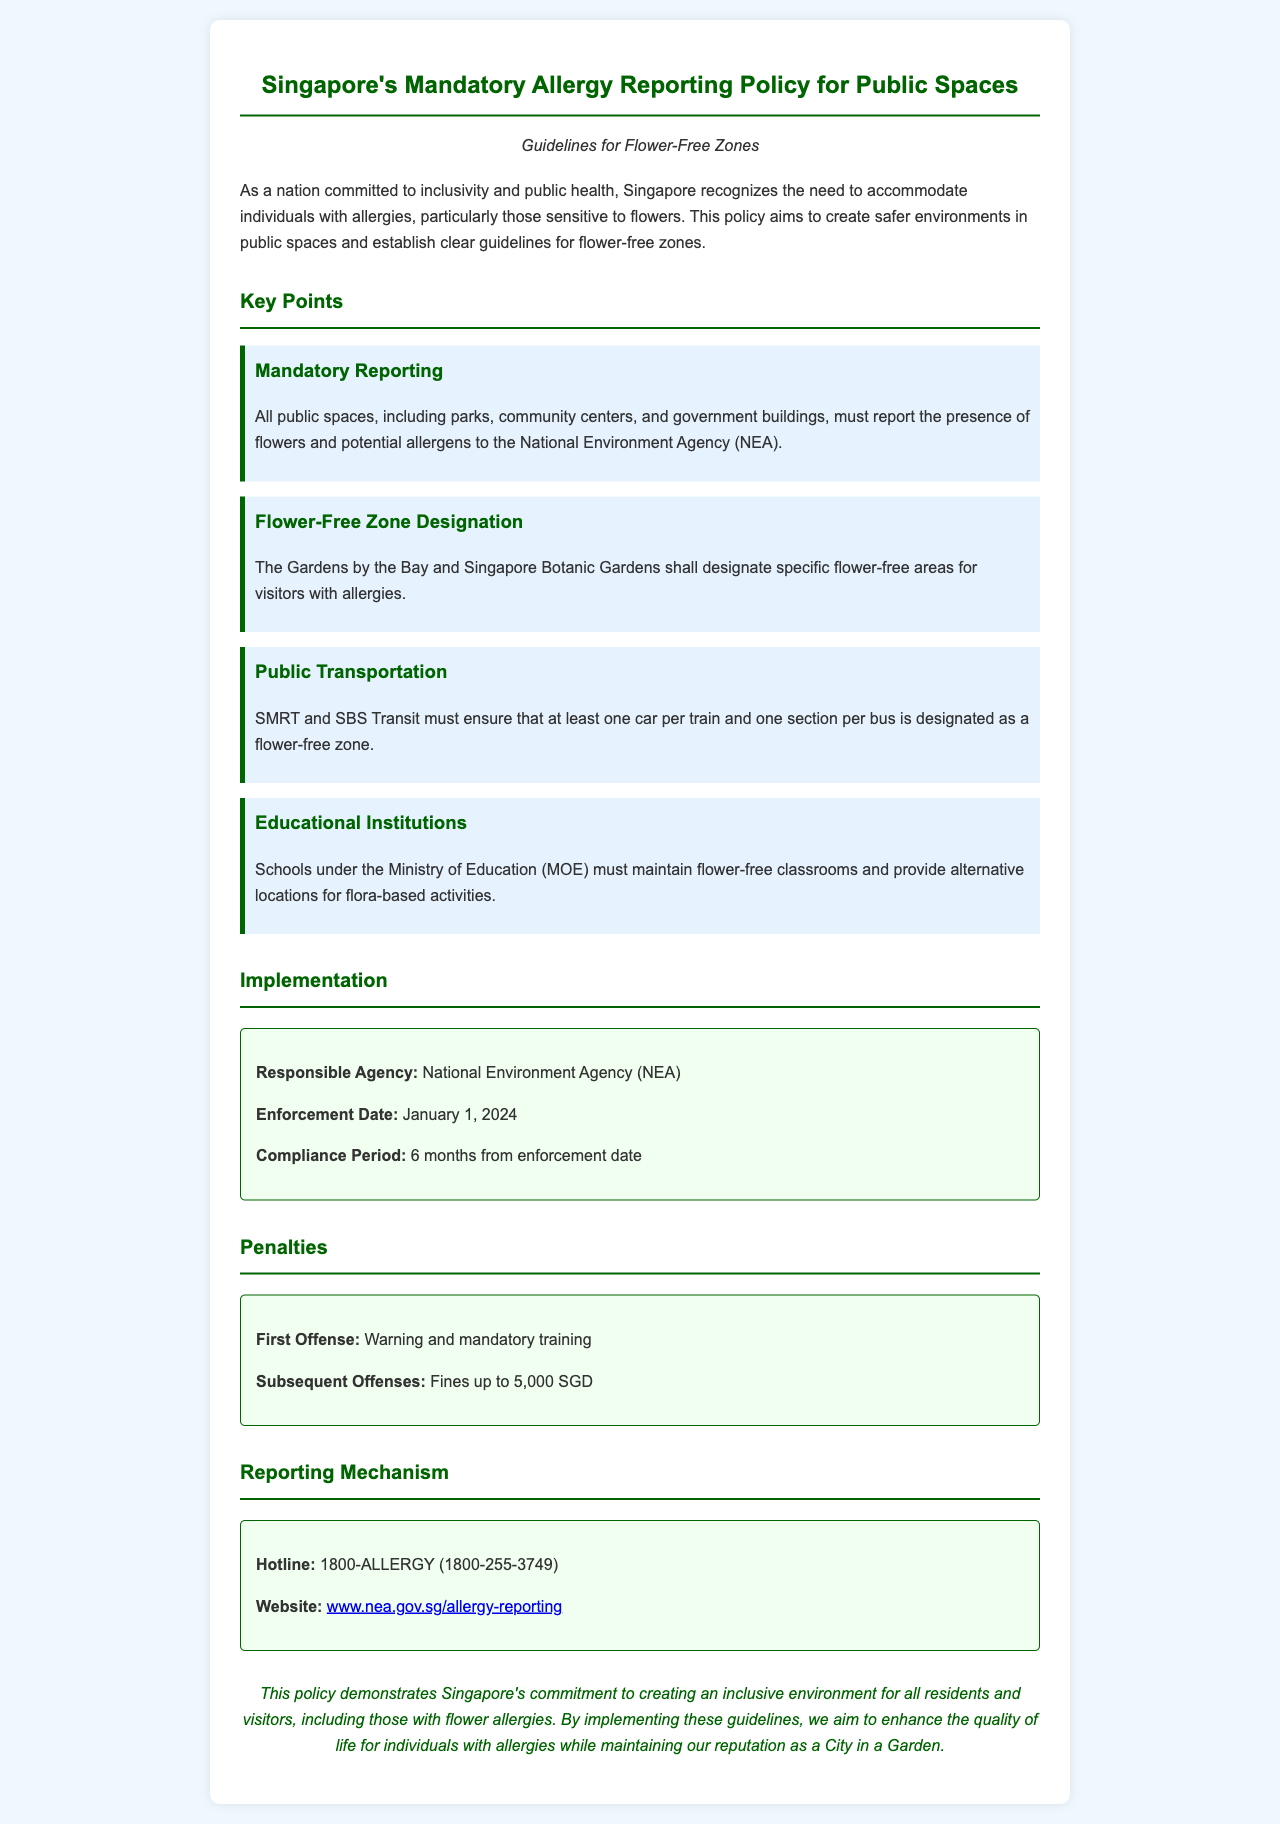What is the enforcement date of the policy? The enforcement date is specified in the document as the date when the policy will become active.
Answer: January 1, 2024 Who is responsible for implementing the policy? The document clearly states which agency is tasked with the implementation of the policy.
Answer: National Environment Agency (NEA) What is the maximum fine for subsequent offenses? This figure indicates the penalty amount for repeated violations of the policy as stipulated in the document.
Answer: 5,000 SGD What must public transportation ensure regarding flower-free zones? The document outlines the specific requirements for public transportation regarding allergy accommodations.
Answer: At least one car per train and one section per bus How long is the compliance period after enforcement? The compliance period provides a timeframe for organizations to adhere to the new regulations as mentioned in the document.
Answer: 6 months Which areas are designated as flower-free zones? The document lists specific locations identified for flower-free accommodations for people with allergies.
Answer: Gardens by the Bay and Singapore Botanic Gardens What kind of training is mandated for first-time offenders? The policy specifies actions that offenders must undergo upon their first violation, which is a type of training.
Answer: Mandatory training What is the hotline number for reporting allergies? The document provides a contact number for individuals to report allergies, which is an essential aspect of the policy.
Answer: 1800-ALLERGY (1800-255-3749) 